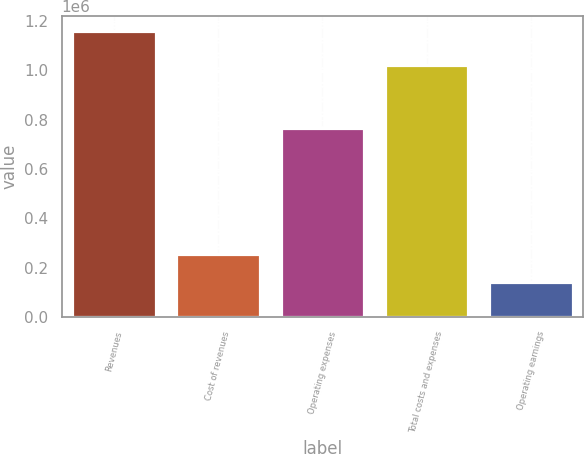<chart> <loc_0><loc_0><loc_500><loc_500><bar_chart><fcel>Revenues<fcel>Cost of revenues<fcel>Operating expenses<fcel>Total costs and expenses<fcel>Operating earnings<nl><fcel>1.16078e+06<fcel>254686<fcel>765663<fcel>1.02035e+06<fcel>140436<nl></chart> 